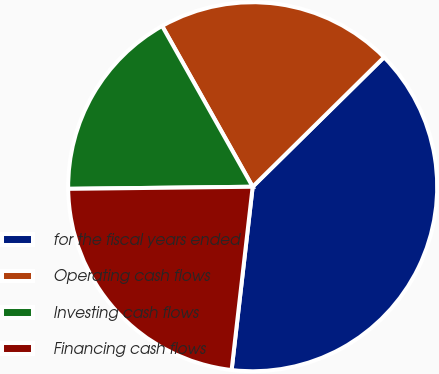Convert chart. <chart><loc_0><loc_0><loc_500><loc_500><pie_chart><fcel>for the fiscal years ended<fcel>Operating cash flows<fcel>Investing cash flows<fcel>Financing cash flows<nl><fcel>39.21%<fcel>20.78%<fcel>17.02%<fcel>23.0%<nl></chart> 